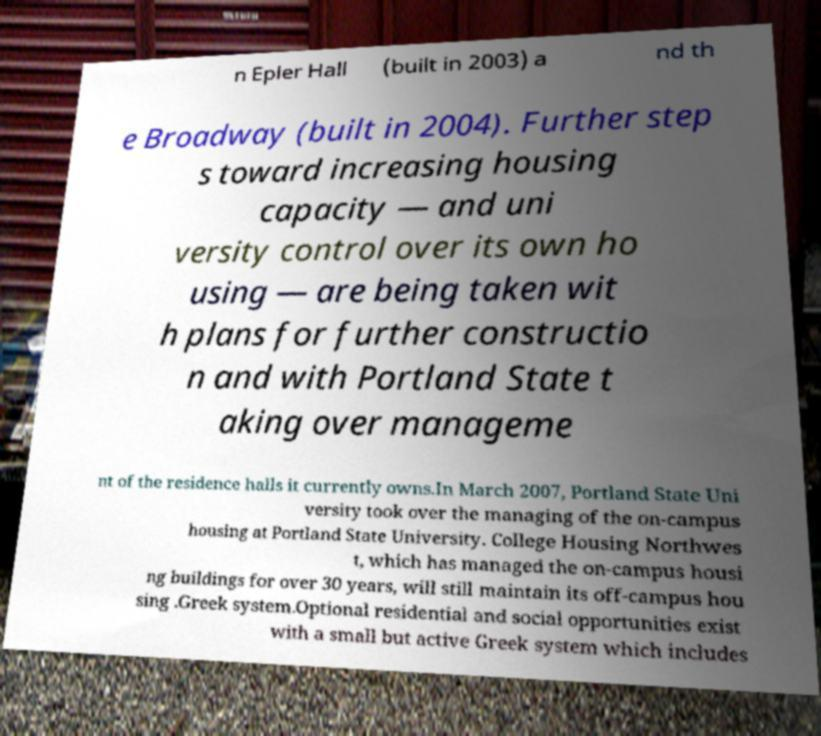For documentation purposes, I need the text within this image transcribed. Could you provide that? n Epler Hall (built in 2003) a nd th e Broadway (built in 2004). Further step s toward increasing housing capacity — and uni versity control over its own ho using — are being taken wit h plans for further constructio n and with Portland State t aking over manageme nt of the residence halls it currently owns.In March 2007, Portland State Uni versity took over the managing of the on-campus housing at Portland State University. College Housing Northwes t, which has managed the on-campus housi ng buildings for over 30 years, will still maintain its off-campus hou sing .Greek system.Optional residential and social opportunities exist with a small but active Greek system which includes 